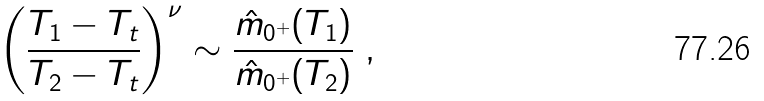Convert formula to latex. <formula><loc_0><loc_0><loc_500><loc_500>\left ( \frac { T _ { 1 } - T _ { t } } { T _ { 2 } - T _ { t } } \right ) ^ { \nu } \sim \frac { \hat { m } _ { 0 ^ { + } } ( T _ { 1 } ) } { \hat { m } _ { 0 ^ { + } } ( T _ { 2 } ) } \ ,</formula> 